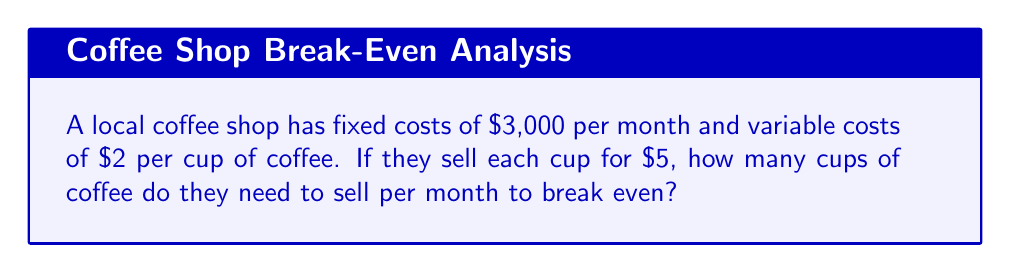Provide a solution to this math problem. Let's approach this step-by-step:

1. Define the variables:
   Let $x$ be the number of cups of coffee sold per month.

2. Calculate the total revenue:
   Revenue = Price per cup × Number of cups
   $R = 5x$

3. Calculate the total cost:
   Total Cost = Fixed Costs + Variable Costs
   $C = 3000 + 2x$

4. At the break-even point, total revenue equals total cost:
   $R = C$
   $5x = 3000 + 2x$

5. Solve the equation:
   $5x - 2x = 3000$
   $3x = 3000$
   $x = 1000$

Therefore, the coffee shop needs to sell 1,000 cups of coffee per month to break even.

To verify:
Revenue: $5 × 1000 = $5000
Costs: $3000 + ($2 × 1000) = $5000
Answer: 1,000 cups 